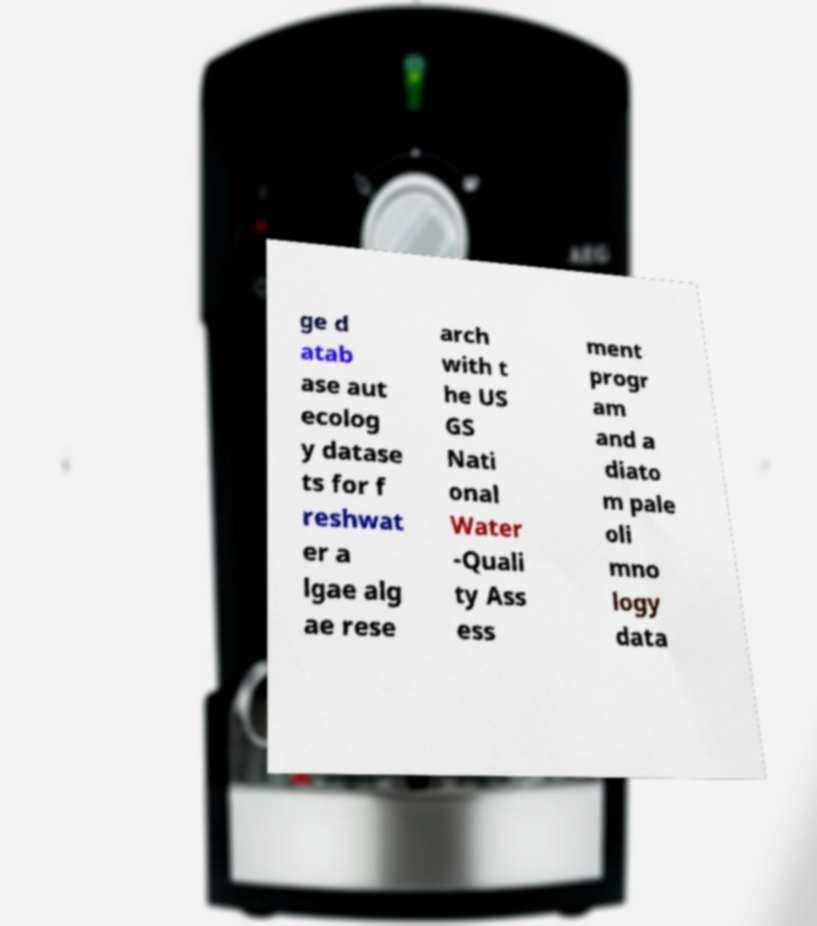I need the written content from this picture converted into text. Can you do that? ge d atab ase aut ecolog y datase ts for f reshwat er a lgae alg ae rese arch with t he US GS Nati onal Water -Quali ty Ass ess ment progr am and a diato m pale oli mno logy data 